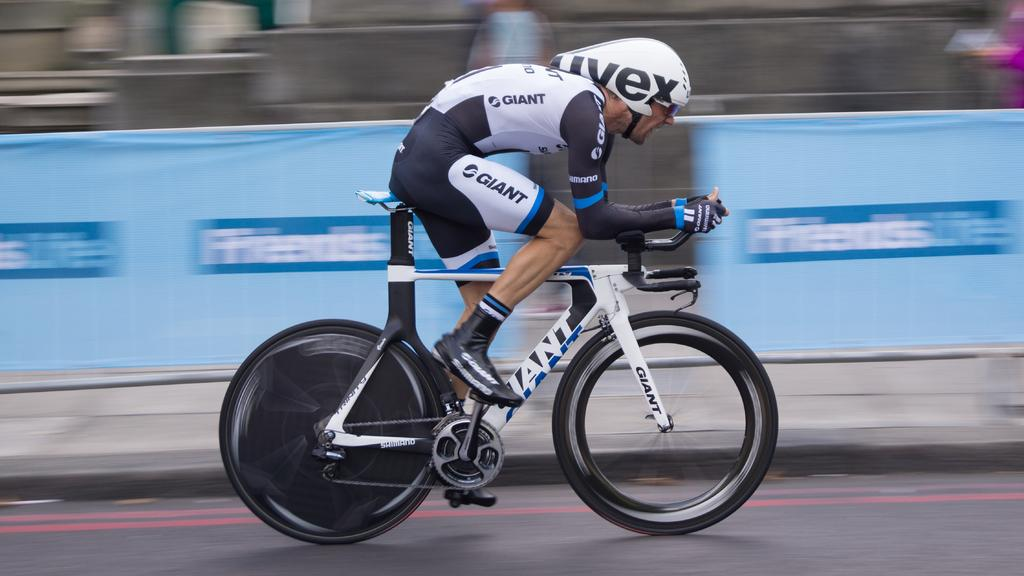<image>
Give a short and clear explanation of the subsequent image. Man racing on a bike wearing Giant brand all over. 